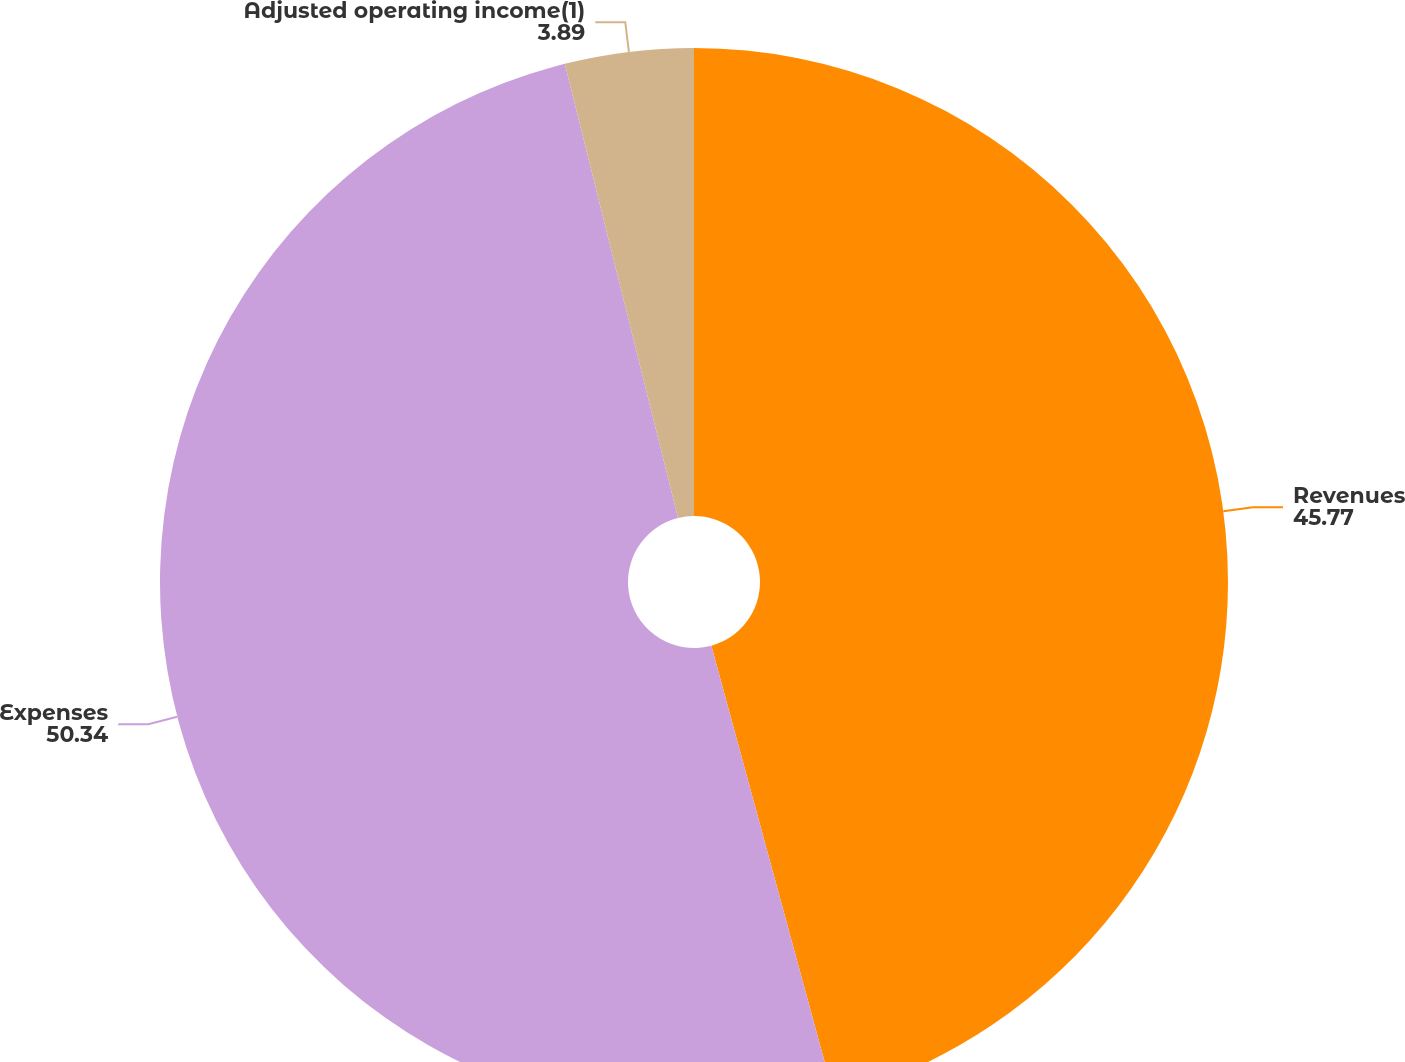<chart> <loc_0><loc_0><loc_500><loc_500><pie_chart><fcel>Revenues<fcel>Expenses<fcel>Adjusted operating income(1)<nl><fcel>45.77%<fcel>50.34%<fcel>3.89%<nl></chart> 